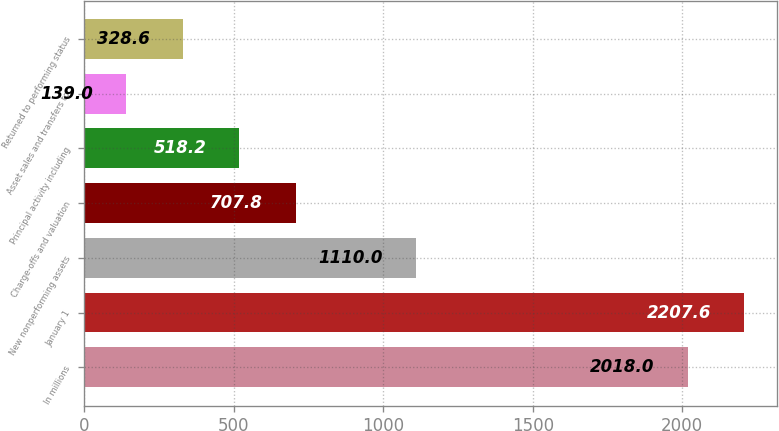Convert chart to OTSL. <chart><loc_0><loc_0><loc_500><loc_500><bar_chart><fcel>In millions<fcel>January 1<fcel>New nonperforming assets<fcel>Charge-offs and valuation<fcel>Principal activity including<fcel>Asset sales and transfers to<fcel>Returned to performing status<nl><fcel>2018<fcel>2207.6<fcel>1110<fcel>707.8<fcel>518.2<fcel>139<fcel>328.6<nl></chart> 